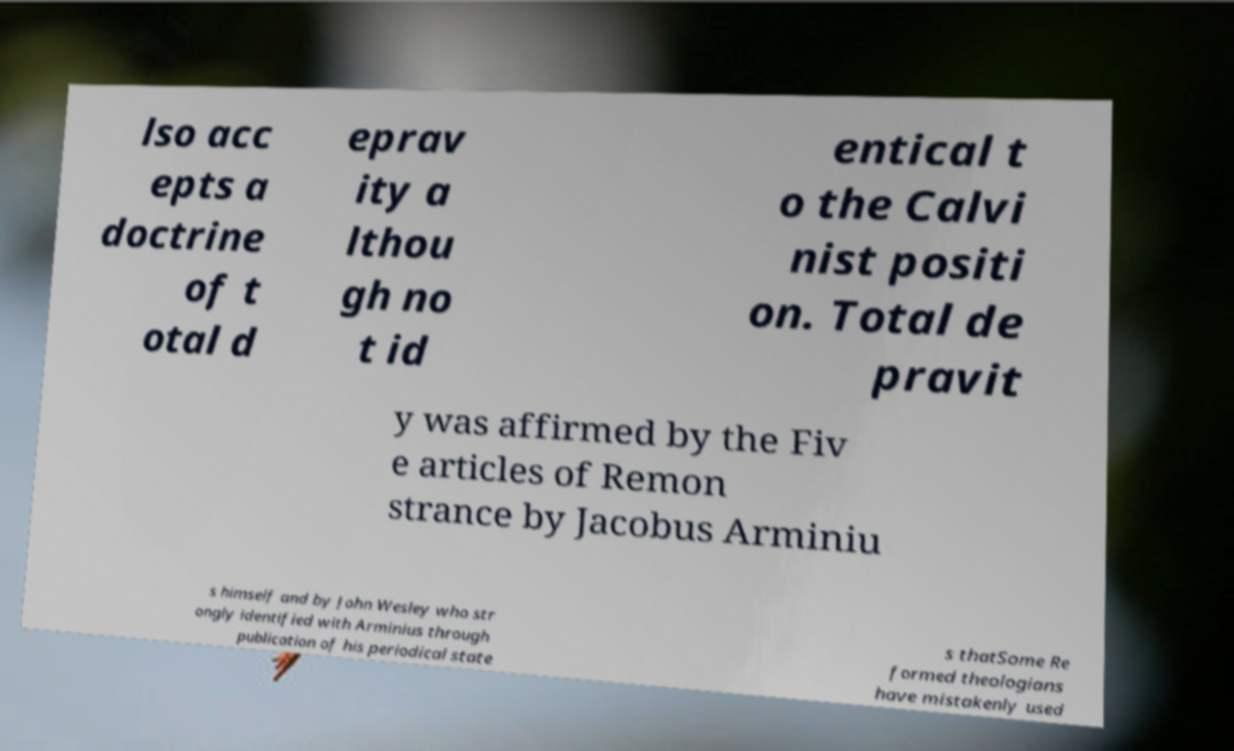What messages or text are displayed in this image? I need them in a readable, typed format. lso acc epts a doctrine of t otal d eprav ity a lthou gh no t id entical t o the Calvi nist positi on. Total de pravit y was affirmed by the Fiv e articles of Remon strance by Jacobus Arminiu s himself and by John Wesley who str ongly identified with Arminius through publication of his periodical state s thatSome Re formed theologians have mistakenly used 